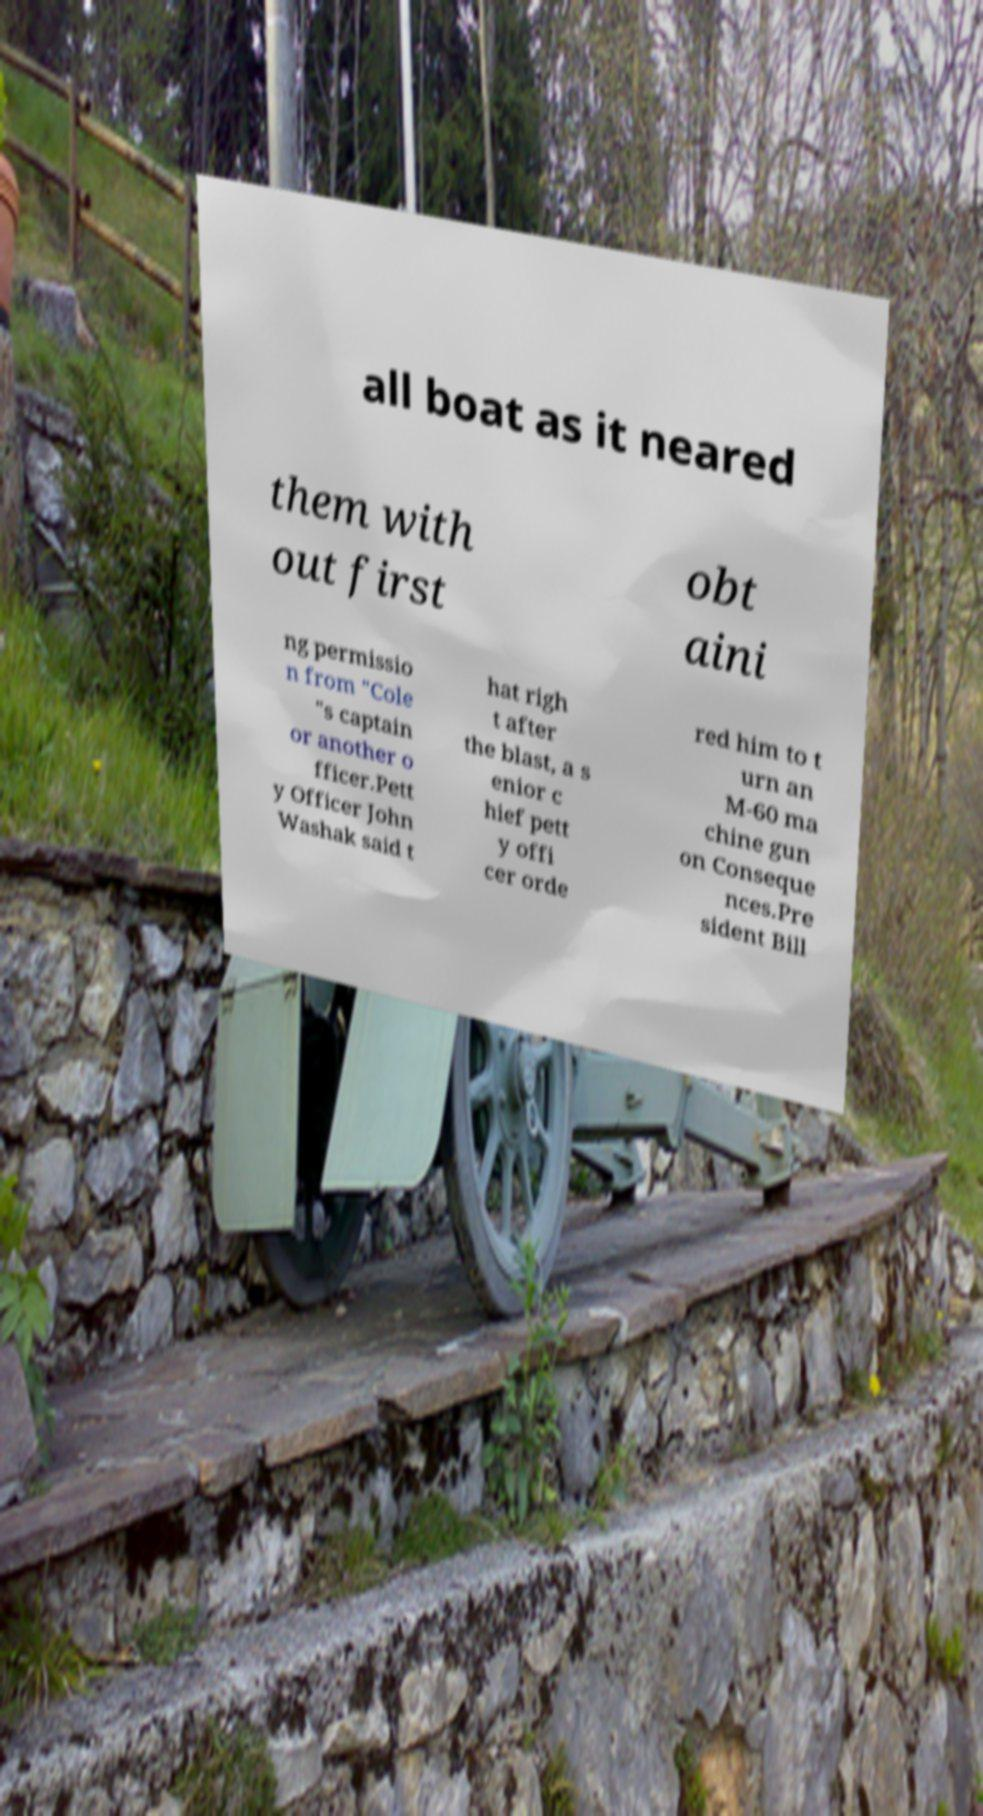Could you extract and type out the text from this image? all boat as it neared them with out first obt aini ng permissio n from "Cole "s captain or another o fficer.Pett y Officer John Washak said t hat righ t after the blast, a s enior c hief pett y offi cer orde red him to t urn an M-60 ma chine gun on Conseque nces.Pre sident Bill 